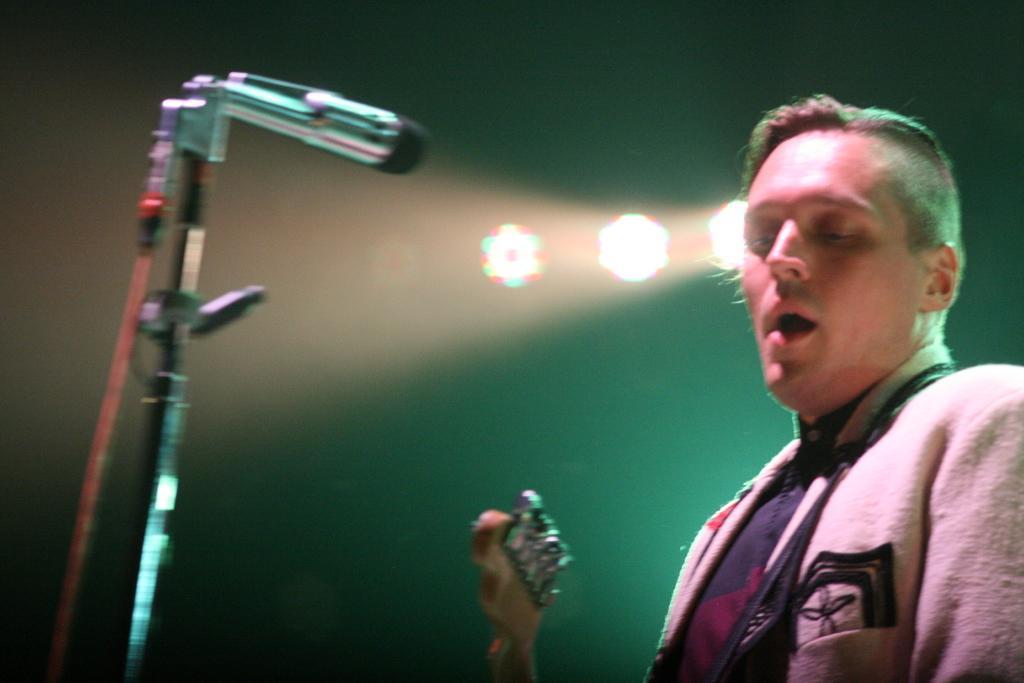Can you describe this image briefly? On the right side of the image there is a person holding the guitar. In front of him there is a mike. Behind him there are lights. 